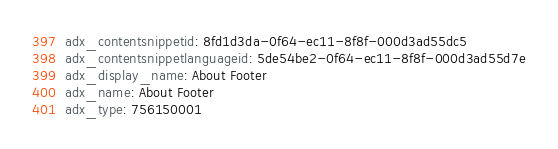<code> <loc_0><loc_0><loc_500><loc_500><_YAML_>adx_contentsnippetid: 8fd1d3da-0f64-ec11-8f8f-000d3ad55dc5
adx_contentsnippetlanguageid: 5de54be2-0f64-ec11-8f8f-000d3ad55d7e
adx_display_name: About Footer
adx_name: About Footer
adx_type: 756150001
</code> 